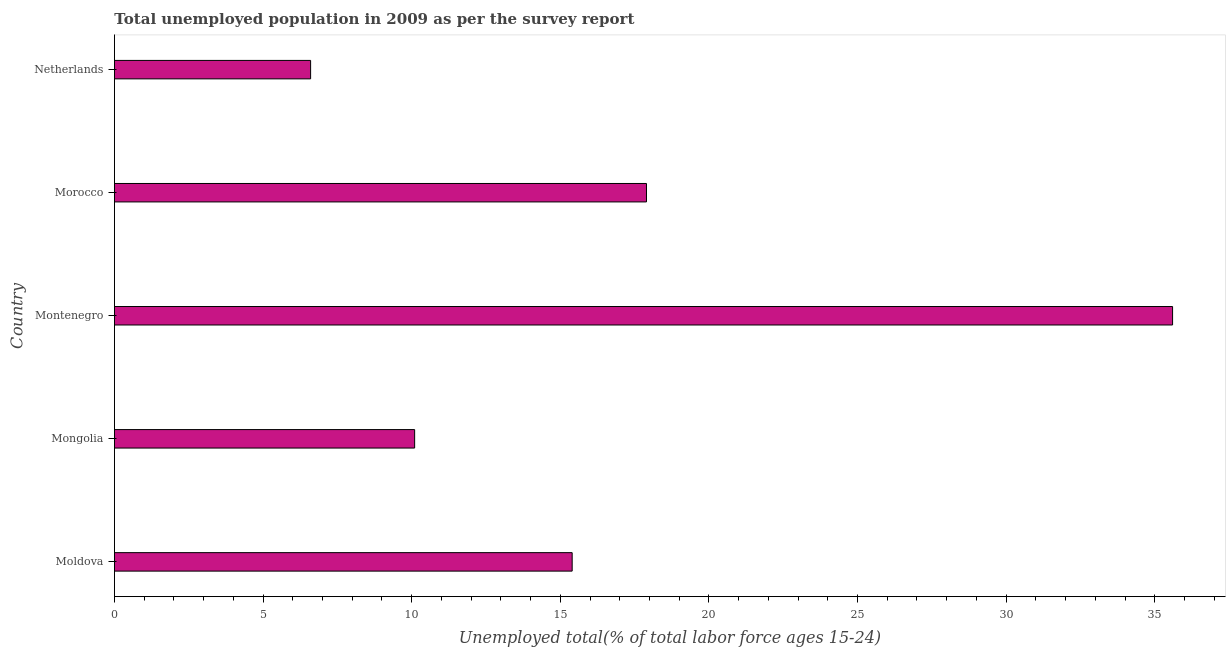What is the title of the graph?
Provide a short and direct response. Total unemployed population in 2009 as per the survey report. What is the label or title of the X-axis?
Your response must be concise. Unemployed total(% of total labor force ages 15-24). What is the label or title of the Y-axis?
Keep it short and to the point. Country. What is the unemployed youth in Mongolia?
Ensure brevity in your answer.  10.1. Across all countries, what is the maximum unemployed youth?
Provide a succinct answer. 35.6. Across all countries, what is the minimum unemployed youth?
Provide a short and direct response. 6.6. In which country was the unemployed youth maximum?
Provide a succinct answer. Montenegro. In which country was the unemployed youth minimum?
Offer a very short reply. Netherlands. What is the sum of the unemployed youth?
Offer a very short reply. 85.6. What is the difference between the unemployed youth in Moldova and Netherlands?
Offer a terse response. 8.8. What is the average unemployed youth per country?
Give a very brief answer. 17.12. What is the median unemployed youth?
Make the answer very short. 15.4. In how many countries, is the unemployed youth greater than 34 %?
Ensure brevity in your answer.  1. What is the ratio of the unemployed youth in Mongolia to that in Montenegro?
Your answer should be very brief. 0.28. Is the unemployed youth in Montenegro less than that in Netherlands?
Your response must be concise. No. What is the difference between the highest and the second highest unemployed youth?
Keep it short and to the point. 17.7. What is the difference between the highest and the lowest unemployed youth?
Offer a terse response. 29. In how many countries, is the unemployed youth greater than the average unemployed youth taken over all countries?
Provide a succinct answer. 2. How many bars are there?
Give a very brief answer. 5. What is the Unemployed total(% of total labor force ages 15-24) of Moldova?
Ensure brevity in your answer.  15.4. What is the Unemployed total(% of total labor force ages 15-24) in Mongolia?
Offer a terse response. 10.1. What is the Unemployed total(% of total labor force ages 15-24) of Montenegro?
Offer a terse response. 35.6. What is the Unemployed total(% of total labor force ages 15-24) of Morocco?
Offer a terse response. 17.9. What is the Unemployed total(% of total labor force ages 15-24) in Netherlands?
Your answer should be compact. 6.6. What is the difference between the Unemployed total(% of total labor force ages 15-24) in Moldova and Montenegro?
Give a very brief answer. -20.2. What is the difference between the Unemployed total(% of total labor force ages 15-24) in Mongolia and Montenegro?
Offer a very short reply. -25.5. What is the difference between the Unemployed total(% of total labor force ages 15-24) in Montenegro and Morocco?
Your answer should be very brief. 17.7. What is the difference between the Unemployed total(% of total labor force ages 15-24) in Montenegro and Netherlands?
Provide a short and direct response. 29. What is the difference between the Unemployed total(% of total labor force ages 15-24) in Morocco and Netherlands?
Offer a very short reply. 11.3. What is the ratio of the Unemployed total(% of total labor force ages 15-24) in Moldova to that in Mongolia?
Offer a terse response. 1.52. What is the ratio of the Unemployed total(% of total labor force ages 15-24) in Moldova to that in Montenegro?
Provide a succinct answer. 0.43. What is the ratio of the Unemployed total(% of total labor force ages 15-24) in Moldova to that in Morocco?
Offer a terse response. 0.86. What is the ratio of the Unemployed total(% of total labor force ages 15-24) in Moldova to that in Netherlands?
Keep it short and to the point. 2.33. What is the ratio of the Unemployed total(% of total labor force ages 15-24) in Mongolia to that in Montenegro?
Provide a short and direct response. 0.28. What is the ratio of the Unemployed total(% of total labor force ages 15-24) in Mongolia to that in Morocco?
Ensure brevity in your answer.  0.56. What is the ratio of the Unemployed total(% of total labor force ages 15-24) in Mongolia to that in Netherlands?
Give a very brief answer. 1.53. What is the ratio of the Unemployed total(% of total labor force ages 15-24) in Montenegro to that in Morocco?
Ensure brevity in your answer.  1.99. What is the ratio of the Unemployed total(% of total labor force ages 15-24) in Montenegro to that in Netherlands?
Give a very brief answer. 5.39. What is the ratio of the Unemployed total(% of total labor force ages 15-24) in Morocco to that in Netherlands?
Give a very brief answer. 2.71. 